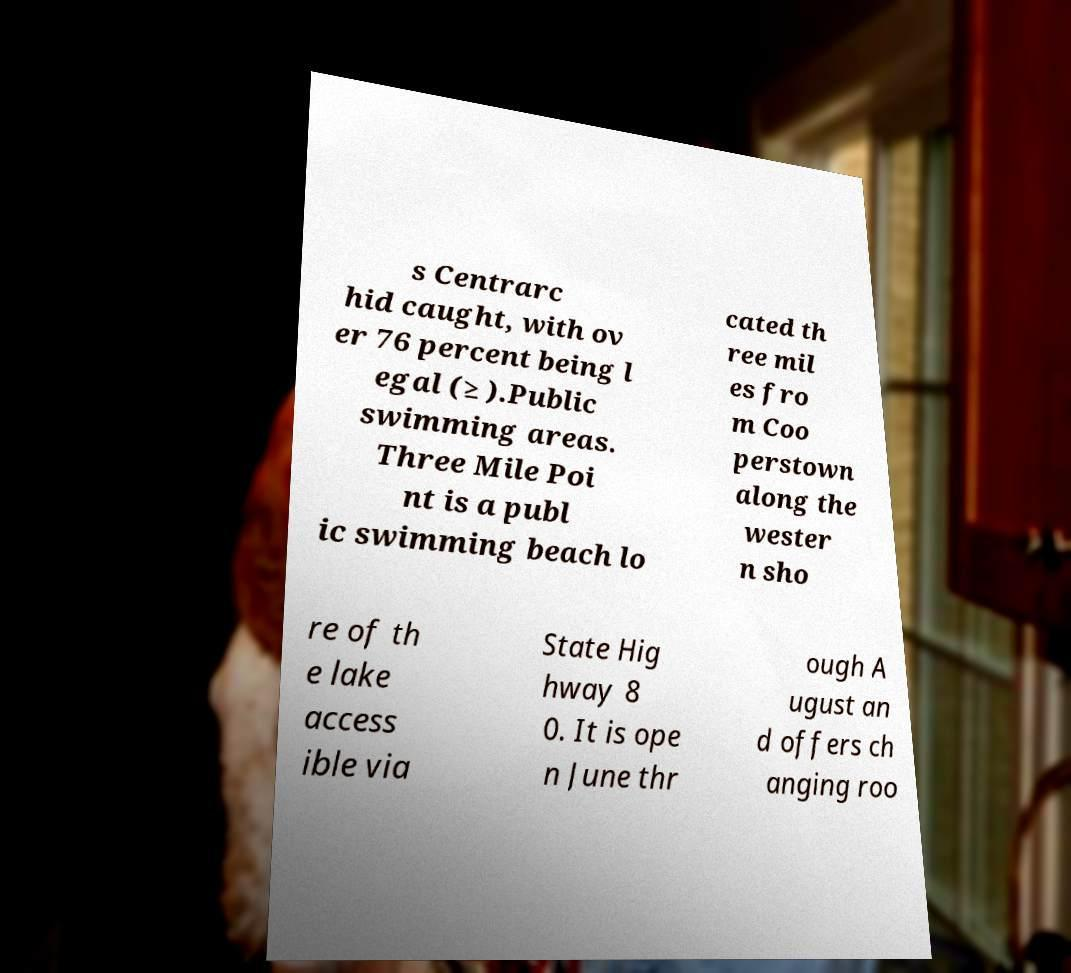Can you accurately transcribe the text from the provided image for me? s Centrarc hid caught, with ov er 76 percent being l egal (≥ ).Public swimming areas. Three Mile Poi nt is a publ ic swimming beach lo cated th ree mil es fro m Coo perstown along the wester n sho re of th e lake access ible via State Hig hway 8 0. It is ope n June thr ough A ugust an d offers ch anging roo 